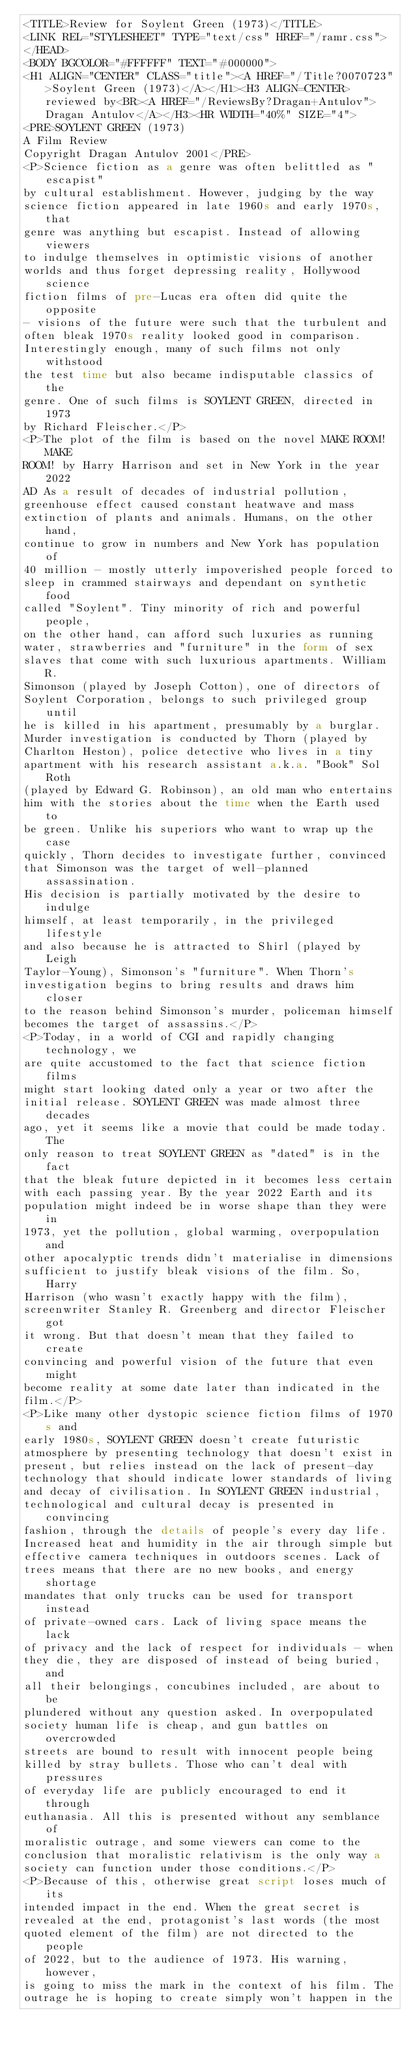<code> <loc_0><loc_0><loc_500><loc_500><_HTML_><TITLE>Review for Soylent Green (1973)</TITLE>
<LINK REL="STYLESHEET" TYPE="text/css" HREF="/ramr.css">
</HEAD>
<BODY BGCOLOR="#FFFFFF" TEXT="#000000">
<H1 ALIGN="CENTER" CLASS="title"><A HREF="/Title?0070723">Soylent Green (1973)</A></H1><H3 ALIGN=CENTER>reviewed by<BR><A HREF="/ReviewsBy?Dragan+Antulov">Dragan Antulov</A></H3><HR WIDTH="40%" SIZE="4">
<PRE>SOYLENT GREEN (1973)
A Film Review
Copyright Dragan Antulov 2001</PRE>
<P>Science fiction as a genre was often belittled as "escapist"
by cultural establishment. However, judging by the way
science fiction appeared in late 1960s and early 1970s, that
genre was anything but escapist. Instead of allowing viewers
to indulge themselves in optimistic visions of another
worlds and thus forget depressing reality, Hollywood science
fiction films of pre-Lucas era often did quite the opposite
- visions of the future were such that the turbulent and
often bleak 1970s reality looked good in comparison.
Interestingly enough, many of such films not only withstood
the test time but also became indisputable classics of the
genre. One of such films is SOYLENT GREEN, directed in 1973
by Richard Fleischer.</P>
<P>The plot of the film is based on the novel MAKE ROOM! MAKE
ROOM! by Harry Harrison and set in New York in the year 2022
AD As a result of decades of industrial pollution,
greenhouse effect caused constant heatwave and mass
extinction of plants and animals. Humans, on the other hand,
continue to grow in numbers and New York has population of
40 million - mostly utterly impoverished people forced to
sleep in crammed stairways and dependant on synthetic food
called "Soylent". Tiny minority of rich and powerful people,
on the other hand, can afford such luxuries as running
water, strawberries and "furniture" in the form of sex
slaves that come with such luxurious apartments. William R.
Simonson (played by Joseph Cotton), one of directors of
Soylent Corporation, belongs to such privileged group until
he is killed in his apartment, presumably by a burglar.
Murder investigation is conducted by Thorn (played by
Charlton Heston), police detective who lives in a tiny
apartment with his research assistant a.k.a. "Book" Sol Roth
(played by Edward G. Robinson), an old man who entertains
him with the stories about the time when the Earth used to
be green. Unlike his superiors who want to wrap up the case
quickly, Thorn decides to investigate further, convinced
that Simonson was the target of well-planned assassination.
His decision is partially motivated by the desire to indulge
himself, at least temporarily, in the privileged lifestyle
and also because he is attracted to Shirl (played by Leigh
Taylor-Young), Simonson's "furniture". When Thorn's
investigation begins to bring results and draws him closer
to the reason behind Simonson's murder, policeman himself
becomes the target of assassins.</P>
<P>Today, in a world of CGI and rapidly changing technology, we
are quite accustomed to the fact that science fiction films
might start looking dated only a year or two after the
initial release. SOYLENT GREEN was made almost three decades
ago, yet it seems like a movie that could be made today. The
only reason to treat SOYLENT GREEN as "dated" is in the fact
that the bleak future depicted in it becomes less certain
with each passing year. By the year 2022 Earth and its
population might indeed be in worse shape than they were in
1973, yet the pollution, global warming, overpopulation and
other apocalyptic trends didn't materialise in dimensions
sufficient to justify bleak visions of the film. So, Harry
Harrison (who wasn't exactly happy with the film),
screenwriter Stanley R. Greenberg and director Fleischer got
it wrong. But that doesn't mean that they failed to create
convincing and powerful vision of the future that even might
become reality at some date later than indicated in the
film.</P>
<P>Like many other dystopic science fiction films of 1970s and
early 1980s, SOYLENT GREEN doesn't create futuristic
atmosphere by presenting technology that doesn't exist in
present, but relies instead on the lack of present-day
technology that should indicate lower standards of living
and decay of civilisation. In SOYLENT GREEN industrial,
technological and cultural decay is presented in convincing
fashion, through the details of people's every day life.
Increased heat and humidity in the air through simple but
effective camera techniques in outdoors scenes. Lack of
trees means that there are no new books, and energy shortage
mandates that only trucks can be used for transport instead
of private-owned cars. Lack of living space means the lack
of privacy and the lack of respect for individuals - when
they die, they are disposed of instead of being buried, and
all their belongings, concubines included, are about to be
plundered without any question asked. In overpopulated
society human life is cheap, and gun battles on overcrowded
streets are bound to result with innocent people being
killed by stray bullets. Those who can't deal with pressures
of everyday life are publicly encouraged to end it through
euthanasia. All this is presented without any semblance of
moralistic outrage, and some viewers can come to the
conclusion that moralistic relativism is the only way a
society can function under those conditions.</P>
<P>Because of this, otherwise great script loses much of its
intended impact in the end. When the great secret is
revealed at the end, protagonist's last words (the most
quoted element of the film) are not directed to the people
of 2022, but to the audience of 1973. His warning, however,
is going to miss the mark in the context of his film. The
outrage he is hoping to create simply won't happen in the</code> 